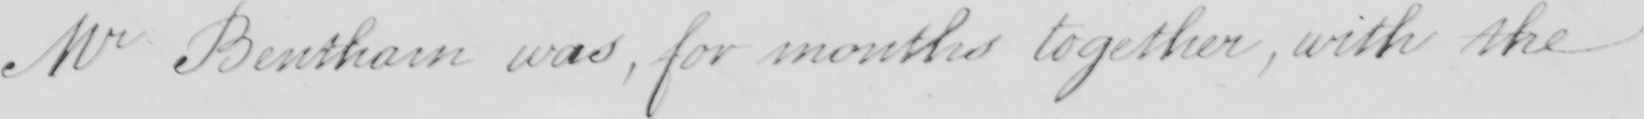What is written in this line of handwriting? Mr Bentham was, for months together, with the 